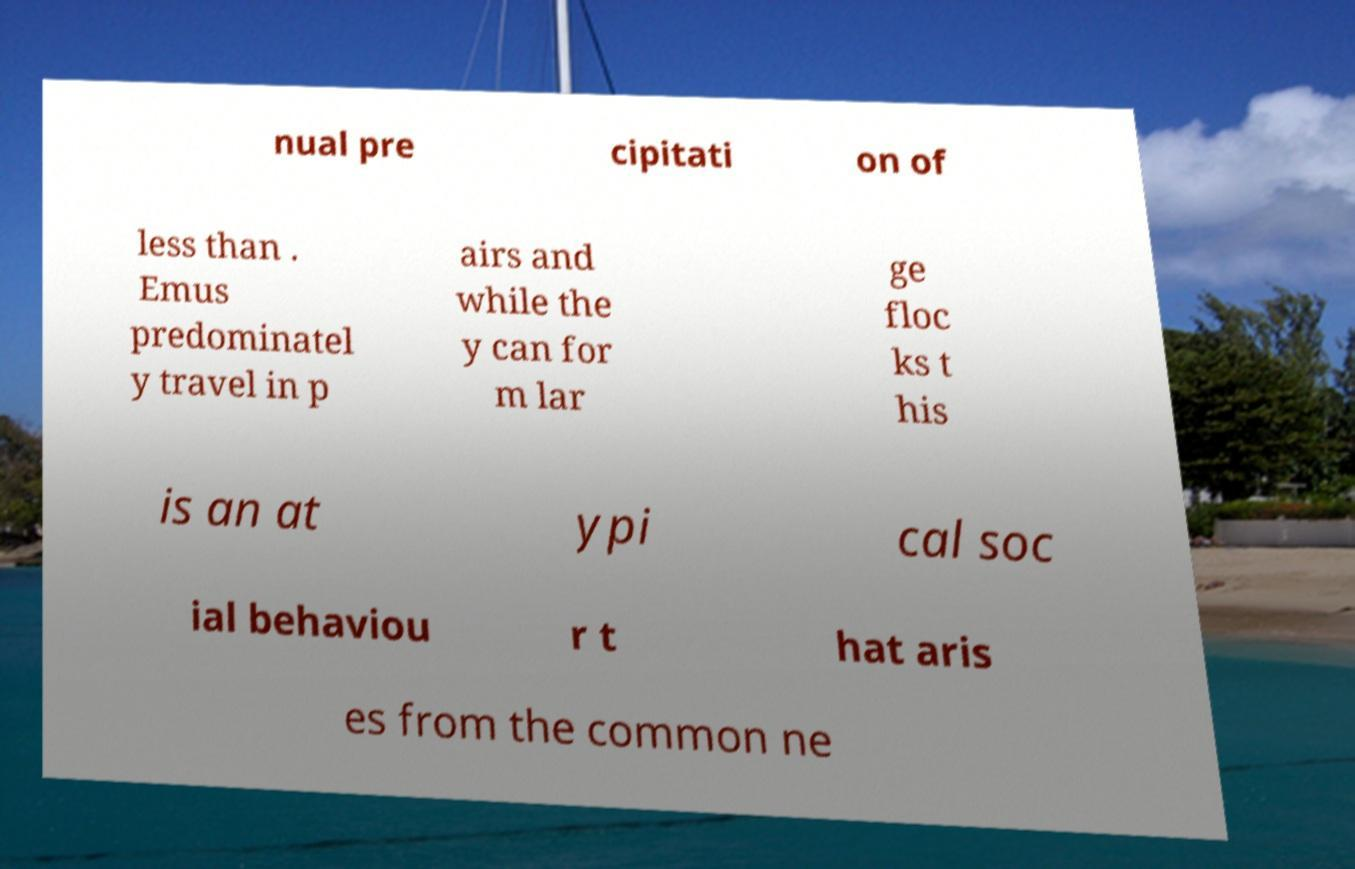Please identify and transcribe the text found in this image. nual pre cipitati on of less than . Emus predominatel y travel in p airs and while the y can for m lar ge floc ks t his is an at ypi cal soc ial behaviou r t hat aris es from the common ne 